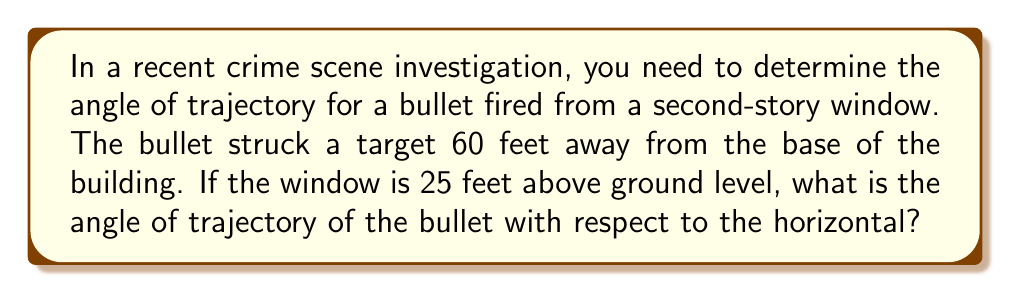Give your solution to this math problem. Let's approach this step-by-step:

1) First, we need to visualize the problem. We have a right triangle where:
   - The horizontal distance (adjacent side) is 60 feet
   - The vertical distance (opposite side) is 25 feet
   - The hypotenuse is the path of the bullet
   - The angle we're looking for is between the hypotenuse and the horizontal

2) We can use the tangent function to find this angle. The tangent of an angle in a right triangle is the ratio of the opposite side to the adjacent side.

3) Let $\theta$ be the angle we're looking for. Then:

   $$\tan(\theta) = \frac{\text{opposite}}{\text{adjacent}} = \frac{25}{60}$$

4) To find $\theta$, we need to use the inverse tangent (arctan or $\tan^{-1}$):

   $$\theta = \tan^{-1}(\frac{25}{60})$$

5) Using a calculator or computer:

   $$\theta \approx 22.62^\circ$$

6) Round to the nearest tenth of a degree:

   $$\theta \approx 22.6^\circ$$

[asy]
import geometry;

size(200);
pair A = (0,0), B = (60,0), C = (0,25);
draw(A--B--C--A);
label("60 ft", (30,0), S);
label("25 ft", (0,12.5), W);
label("$\theta$", (5,3), NE);
draw(arc(A,5,0,22.62), Arrow);
[/asy]
Answer: $22.6^\circ$ 